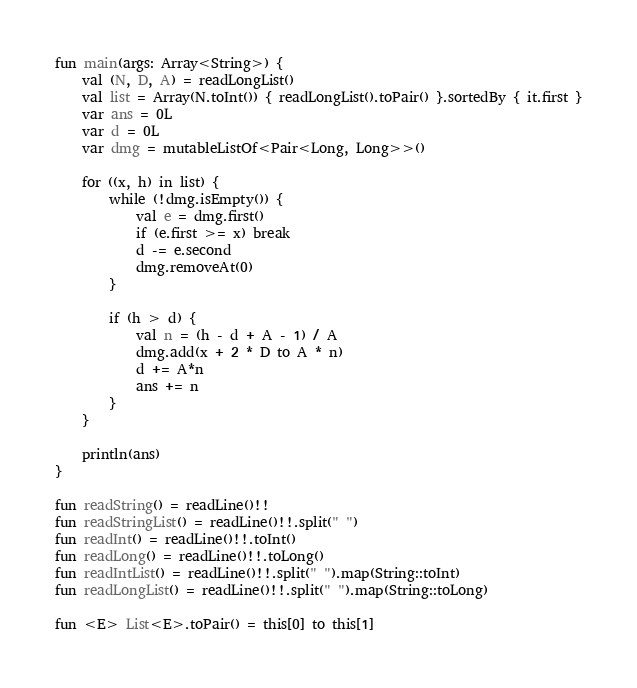Convert code to text. <code><loc_0><loc_0><loc_500><loc_500><_Kotlin_>fun main(args: Array<String>) {
    val (N, D, A) = readLongList()
    val list = Array(N.toInt()) { readLongList().toPair() }.sortedBy { it.first }
    var ans = 0L
    var d = 0L
    var dmg = mutableListOf<Pair<Long, Long>>()

    for ((x, h) in list) {
        while (!dmg.isEmpty()) {
            val e = dmg.first()
            if (e.first >= x) break
            d -= e.second
            dmg.removeAt(0)
        }

        if (h > d) {
            val n = (h - d + A - 1) / A
            dmg.add(x + 2 * D to A * n)
            d += A*n
            ans += n
        }
    }

    println(ans)
}

fun readString() = readLine()!!
fun readStringList() = readLine()!!.split(" ")
fun readInt() = readLine()!!.toInt()
fun readLong() = readLine()!!.toLong()
fun readIntList() = readLine()!!.split(" ").map(String::toInt)
fun readLongList() = readLine()!!.split(" ").map(String::toLong)

fun <E> List<E>.toPair() = this[0] to this[1]
</code> 